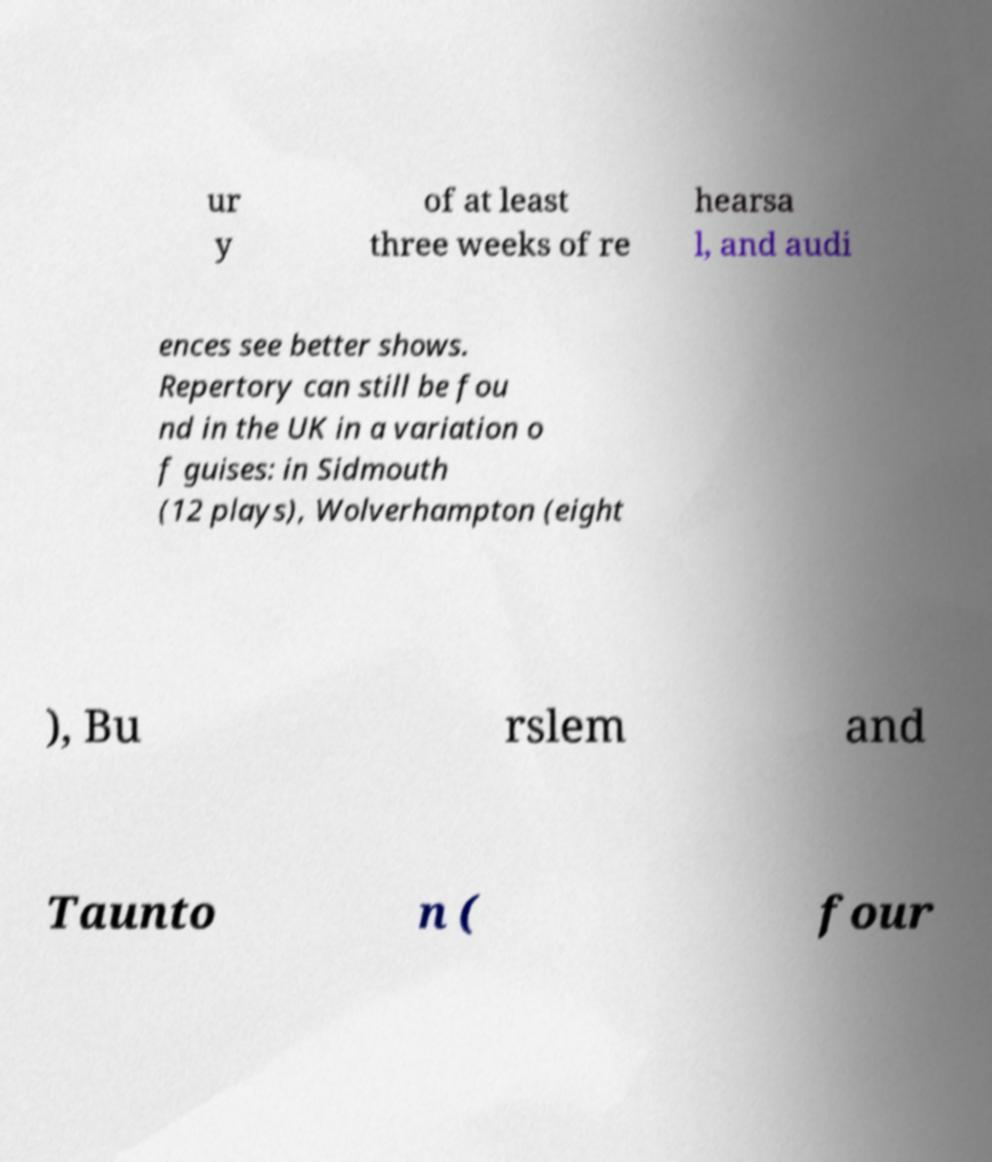Please identify and transcribe the text found in this image. ur y of at least three weeks of re hearsa l, and audi ences see better shows. Repertory can still be fou nd in the UK in a variation o f guises: in Sidmouth (12 plays), Wolverhampton (eight ), Bu rslem and Taunto n ( four 